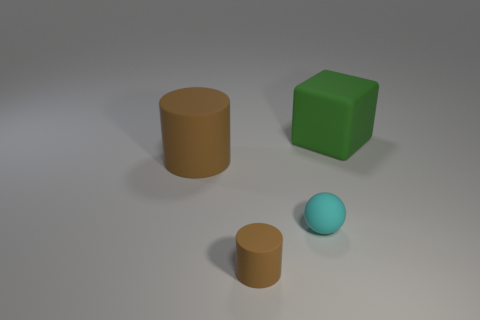Does the tiny thing that is left of the small cyan rubber ball have the same color as the big matte cylinder?
Offer a terse response. Yes. What number of other objects are the same color as the large cylinder?
Keep it short and to the point. 1. There is a rubber object left of the tiny brown rubber object; is its color the same as the matte cylinder that is in front of the large cylinder?
Your answer should be very brief. Yes. Is the material of the brown thing behind the tiny brown thing the same as the big thing behind the big brown rubber thing?
Keep it short and to the point. Yes. How many things are either large cubes that are on the right side of the cyan object or brown cylinders?
Your response must be concise. 3. How many objects are tiny matte spheres or large matte objects to the left of the large green rubber object?
Keep it short and to the point. 2. How many purple rubber things are the same size as the cyan sphere?
Keep it short and to the point. 0. Are there fewer cyan spheres that are on the right side of the ball than big rubber things in front of the green matte cube?
Give a very brief answer. Yes. What number of shiny things are either big brown cylinders or small cyan things?
Your answer should be compact. 0. The tiny brown matte object is what shape?
Offer a very short reply. Cylinder. 